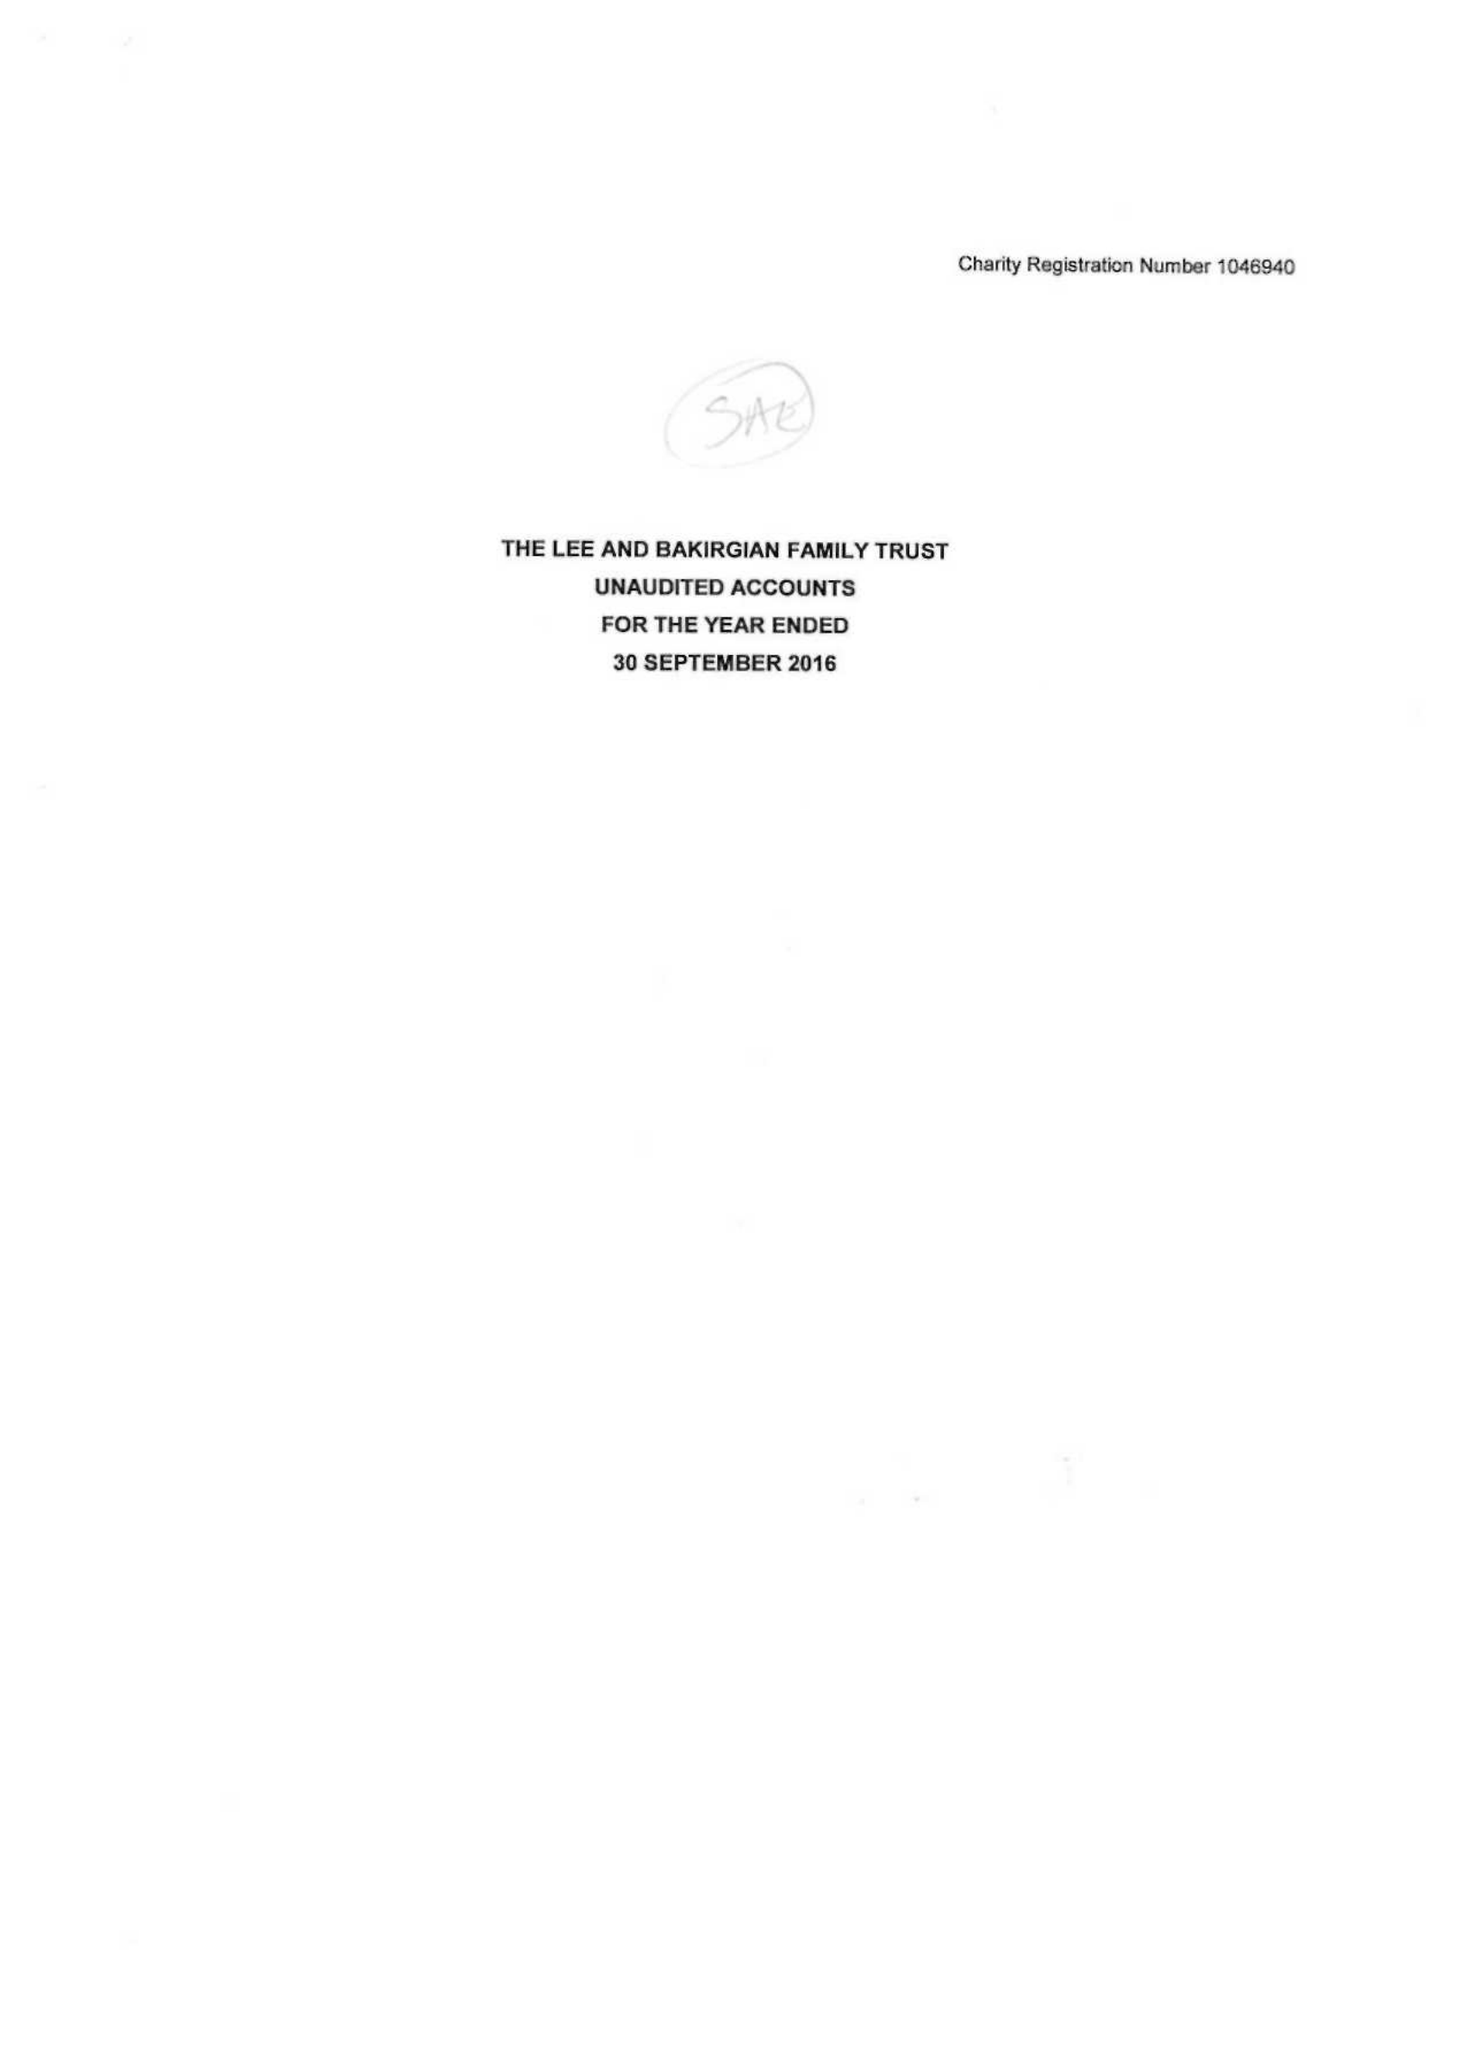What is the value for the address__street_line?
Answer the question using a single word or phrase. YEW TREE WAY 